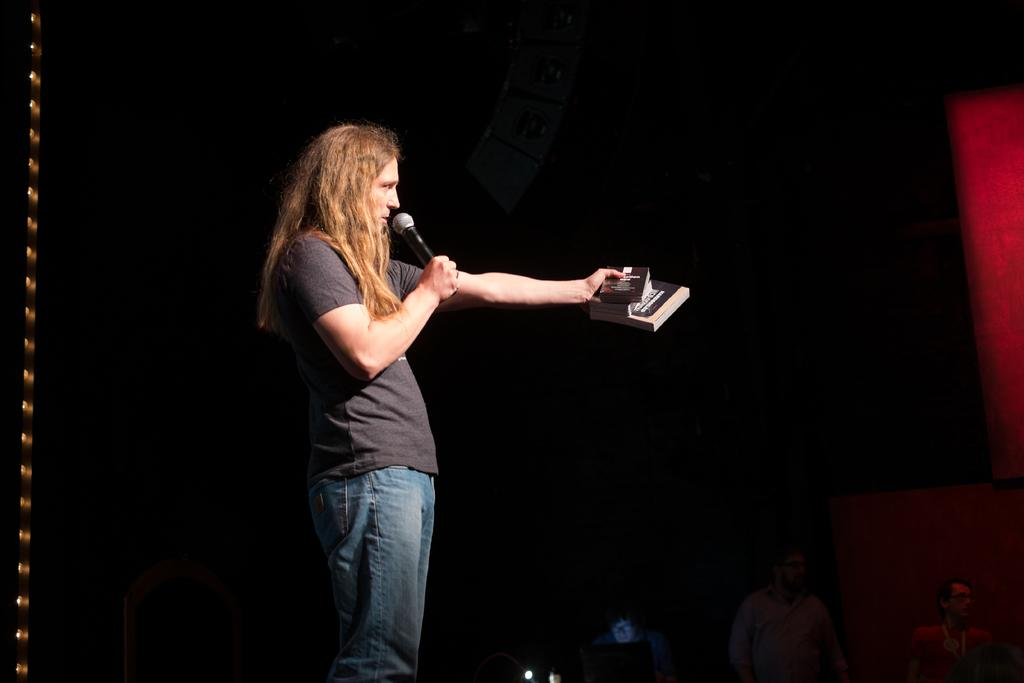Who is the main subject in the image? There is a man in the middle of the image. What is the man wearing? The man is wearing a t-shirt and trousers. What is the man holding in his hands? The man is holding a microphone and books. What can be seen in the background of the image? There are people and light visible in the background of the image. Can you tell me what type of dog is sitting next to the man in the image? There is no dog present in the image; the man is the main subject. What wish does the man make while holding the microphone and books in the image? The image does not provide any information about the man's wishes or intentions, so it cannot be determined from the image. 